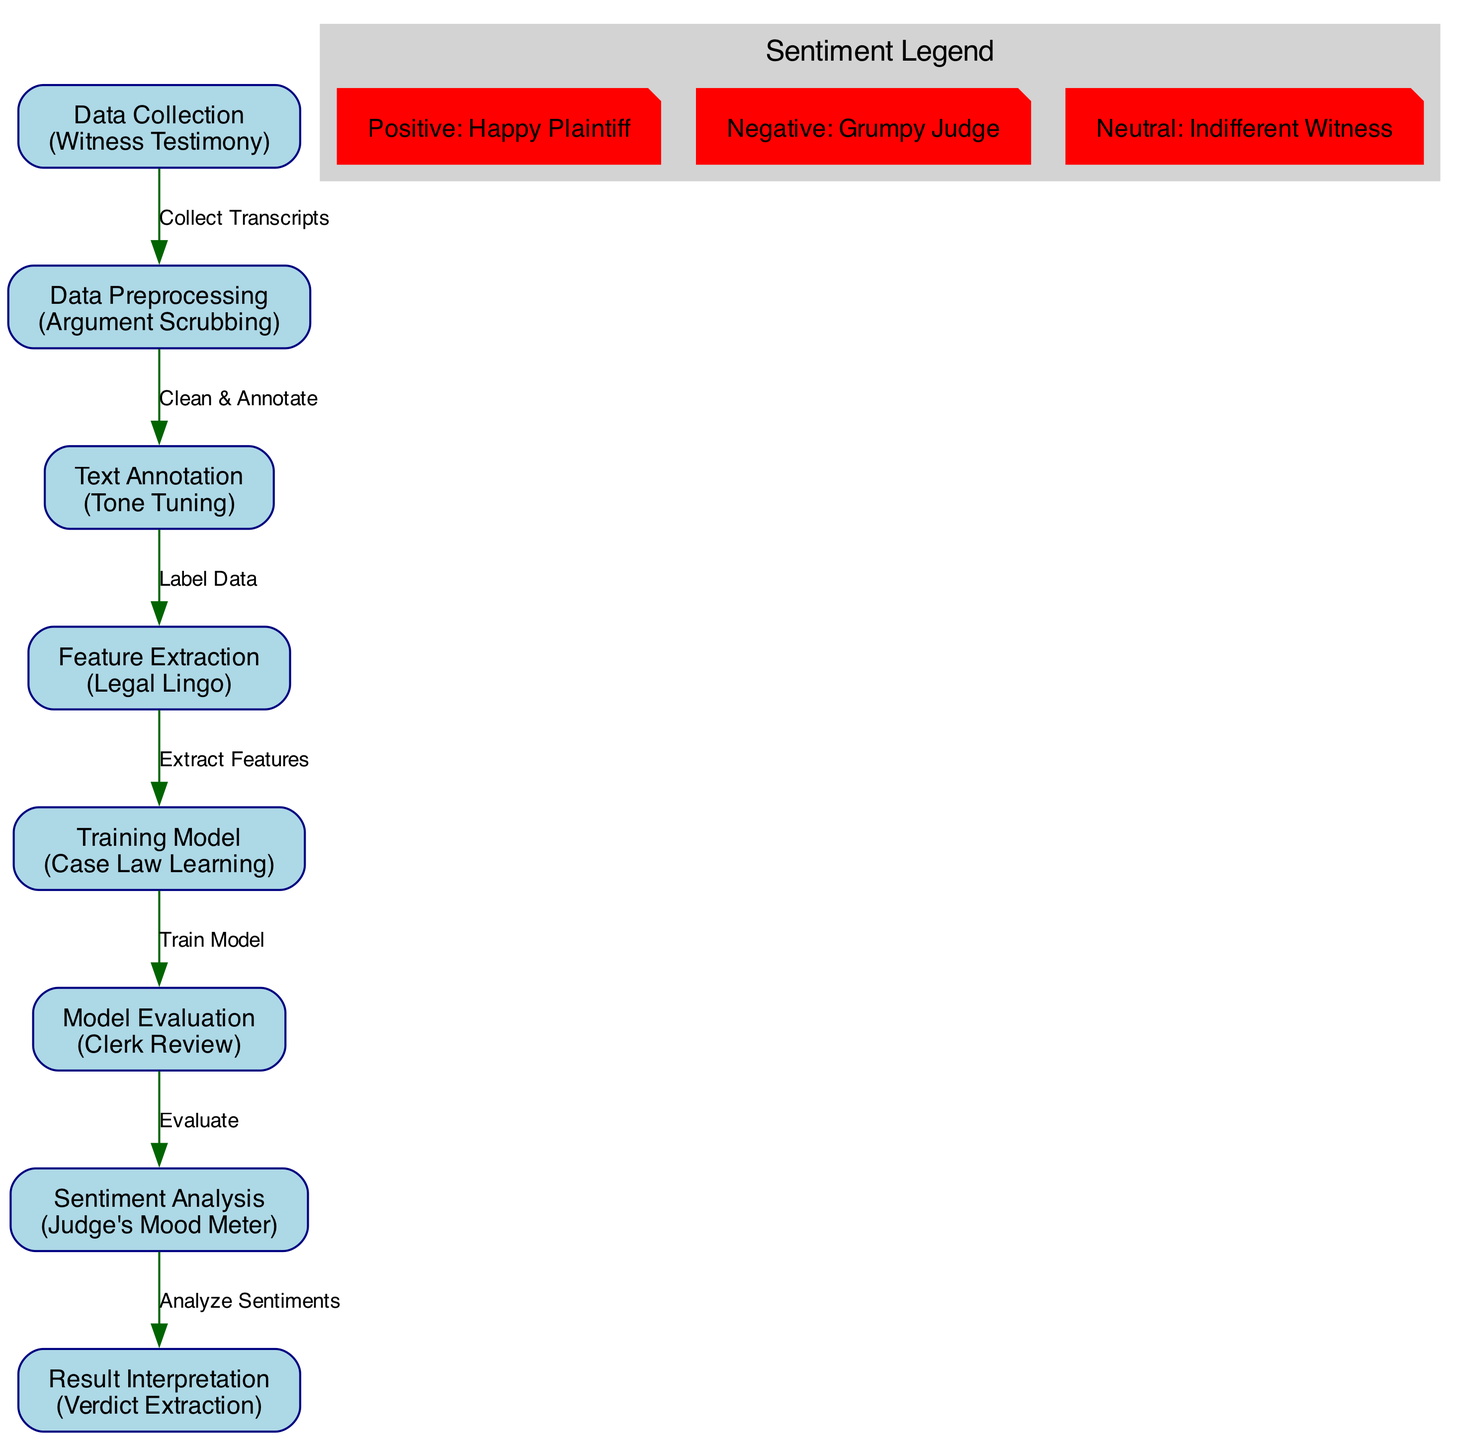What is the first step in the flow? The diagram indicates that the first step is "Data Collection," where courtroom transcripts are gathered. This can be observed directly at the starting node of the diagram.
Answer: Data Collection How many nodes are there in the diagram? By counting each distinct entity represented in the diagram, there are a total of eight nodes including Data Collection, Data Preprocessing, Text Annotation, Feature Extraction, Training Model, Model Evaluation, Sentiment Analysis, and Result Interpretation.
Answer: Eight What step comes after Text Annotation? The flow shows that after Text Annotation, the next step is Feature Extraction, indicating that text annotation directly leads to extracting relevant features.
Answer: Feature Extraction What does the 'Judge's Mood Meter' classify? In the diagram, 'Judge's Mood Meter' is labeled as "Sentiment Analysis," signifying that it is responsible for classifying sentiments based on the processed courtroom data.
Answer: Classifying sentiments Which node involves labeling sentences or phrases with sentiment? The node responsible for labeling sentences or phrases is Text Annotation. This is directly stated in the description provided for that node.
Answer: Text Annotation What playful label is given for negative sentiment? Among the playful labels presented, the negative sentiment is humorously referred to as "Grumpy Judge," providing a light-hearted way of categorizing negative feelings expressed in courtroom transcripts.
Answer: Grumpy Judge What is assessed during the Model Evaluation step? During the Model Evaluation step, the performance of the machine learning model is assessed, ensuring that it meets accuracy standards before proceeding to sentiment analysis.
Answer: Model performance What is the final step in the process? The final step in the sentiment analysis process, according to the diagram, is Result Interpretation, where the outcomes of the sentiment analysis are analyzed for conclusions and implications.
Answer: Result Interpretation 